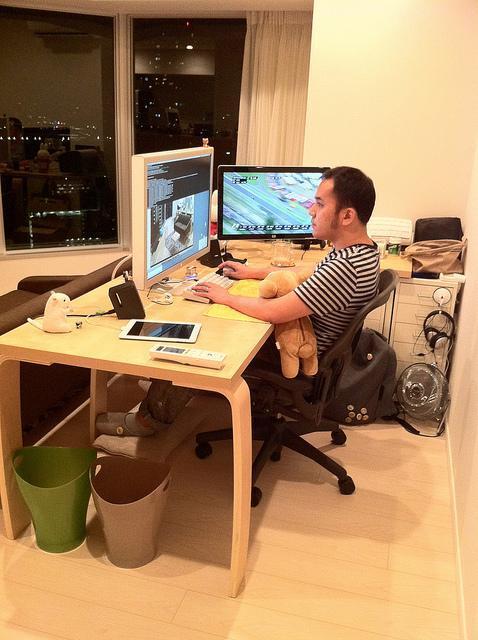How many monitors are on in this picture?
Give a very brief answer. 2. How many waste cans are there?
Give a very brief answer. 2. How many tvs are in the picture?
Give a very brief answer. 2. 